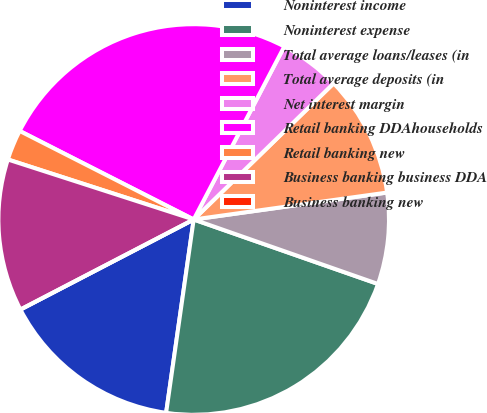Convert chart. <chart><loc_0><loc_0><loc_500><loc_500><pie_chart><fcel>Noninterest income<fcel>Noninterest expense<fcel>Total average loans/leases (in<fcel>Total average deposits (in<fcel>Net interest margin<fcel>Retail banking DDAhouseholds<fcel>Retail banking new<fcel>Business banking business DDA<fcel>Business banking new<nl><fcel>15.12%<fcel>21.9%<fcel>7.56%<fcel>10.08%<fcel>5.04%<fcel>25.19%<fcel>2.52%<fcel>12.6%<fcel>0.0%<nl></chart> 